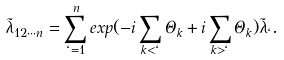<formula> <loc_0><loc_0><loc_500><loc_500>\tilde { \lambda } _ { 1 2 \cdots n } = \sum _ { \ell = 1 } ^ { n } e x p ( - i \sum _ { k < \ell } \Theta _ { k } + i \sum _ { k > \ell } \Theta _ { k } ) \tilde { \lambda } _ { \ell } .</formula> 